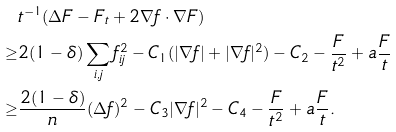Convert formula to latex. <formula><loc_0><loc_0><loc_500><loc_500>& t ^ { - 1 } ( \Delta F - F _ { t } + 2 \nabla f \cdot \nabla F ) \\ \geq & 2 ( 1 - \delta ) \sum _ { i , j } f _ { i j } ^ { 2 } - C _ { 1 } ( | \nabla f | + | \nabla f | ^ { 2 } ) - C _ { 2 } - \frac { F } { t ^ { 2 } } + a \frac { F } { t } \\ \geq & \frac { 2 ( 1 - \delta ) } { n } ( \Delta f ) ^ { 2 } - C _ { 3 } | \nabla f | ^ { 2 } - C _ { 4 } - \frac { F } { t ^ { 2 } } + a \frac { F } { t } .</formula> 